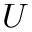<formula> <loc_0><loc_0><loc_500><loc_500>U</formula> 